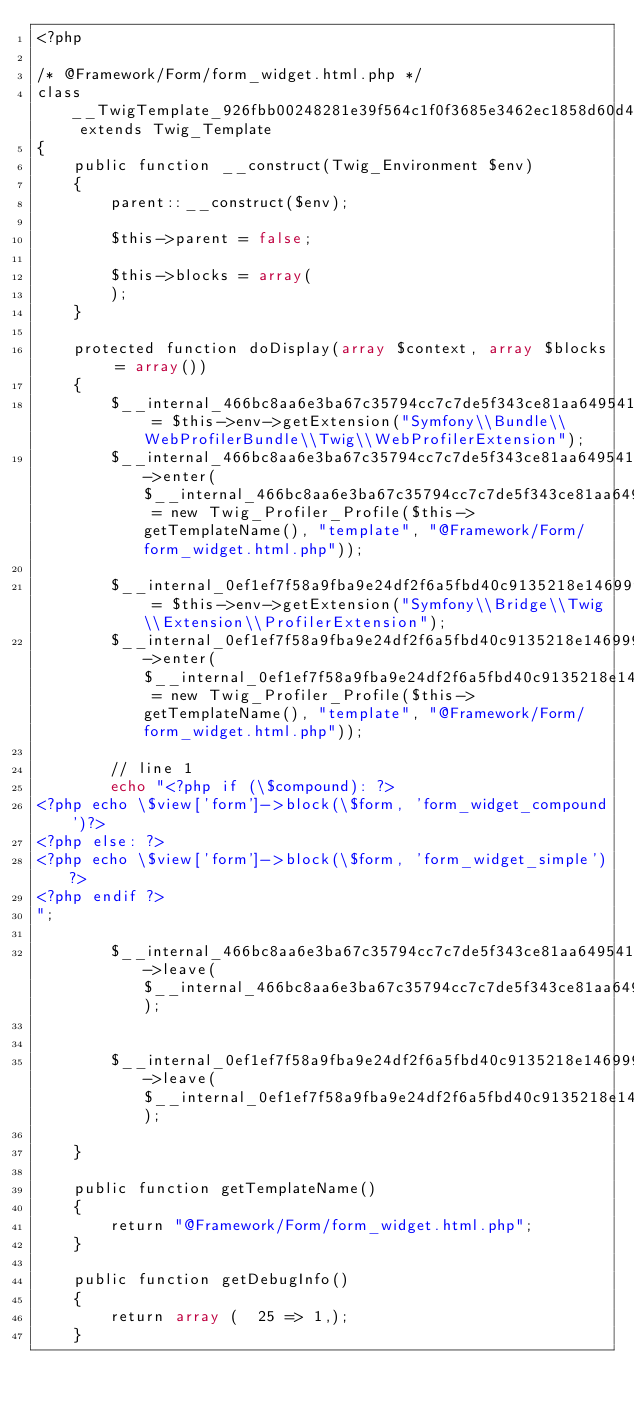<code> <loc_0><loc_0><loc_500><loc_500><_PHP_><?php

/* @Framework/Form/form_widget.html.php */
class __TwigTemplate_926fbb00248281e39f564c1f0f3685e3462ec1858d60d486dd7366fd7e2a204c extends Twig_Template
{
    public function __construct(Twig_Environment $env)
    {
        parent::__construct($env);

        $this->parent = false;

        $this->blocks = array(
        );
    }

    protected function doDisplay(array $context, array $blocks = array())
    {
        $__internal_466bc8aa6e3ba67c35794cc7c7de5f343ce81aa6495419396bb64f251d1f7dd6 = $this->env->getExtension("Symfony\\Bundle\\WebProfilerBundle\\Twig\\WebProfilerExtension");
        $__internal_466bc8aa6e3ba67c35794cc7c7de5f343ce81aa6495419396bb64f251d1f7dd6->enter($__internal_466bc8aa6e3ba67c35794cc7c7de5f343ce81aa6495419396bb64f251d1f7dd6_prof = new Twig_Profiler_Profile($this->getTemplateName(), "template", "@Framework/Form/form_widget.html.php"));

        $__internal_0ef1ef7f58a9fba9e24df2f6a5fbd40c9135218e1469990ee3e3763576a664fd = $this->env->getExtension("Symfony\\Bridge\\Twig\\Extension\\ProfilerExtension");
        $__internal_0ef1ef7f58a9fba9e24df2f6a5fbd40c9135218e1469990ee3e3763576a664fd->enter($__internal_0ef1ef7f58a9fba9e24df2f6a5fbd40c9135218e1469990ee3e3763576a664fd_prof = new Twig_Profiler_Profile($this->getTemplateName(), "template", "@Framework/Form/form_widget.html.php"));

        // line 1
        echo "<?php if (\$compound): ?>
<?php echo \$view['form']->block(\$form, 'form_widget_compound')?>
<?php else: ?>
<?php echo \$view['form']->block(\$form, 'form_widget_simple')?>
<?php endif ?>
";
        
        $__internal_466bc8aa6e3ba67c35794cc7c7de5f343ce81aa6495419396bb64f251d1f7dd6->leave($__internal_466bc8aa6e3ba67c35794cc7c7de5f343ce81aa6495419396bb64f251d1f7dd6_prof);

        
        $__internal_0ef1ef7f58a9fba9e24df2f6a5fbd40c9135218e1469990ee3e3763576a664fd->leave($__internal_0ef1ef7f58a9fba9e24df2f6a5fbd40c9135218e1469990ee3e3763576a664fd_prof);

    }

    public function getTemplateName()
    {
        return "@Framework/Form/form_widget.html.php";
    }

    public function getDebugInfo()
    {
        return array (  25 => 1,);
    }
</code> 